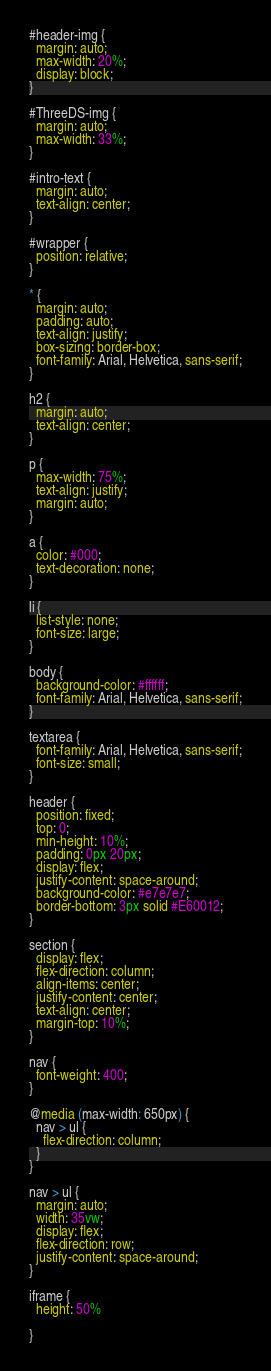<code> <loc_0><loc_0><loc_500><loc_500><_CSS_>#header-img {
  margin: auto;
  max-width: 20%;
  display: block;
}

#ThreeDS-img {
  margin: auto;
  max-width: 33%;
}

#intro-text {
  margin: auto;
  text-align: center;
}

#wrapper {
  position: relative;
}

* {
  margin: auto;
  padding: auto;
  text-align: justify;
  box-sizing: border-box;
  font-family: Arial, Helvetica, sans-serif;
}

h2 {
  margin: auto;
  text-align: center;
}

p {
  max-width: 75%;
  text-align: justify;
  margin: auto;
}

a {
  color: #000;
  text-decoration: none;
}

li {
  list-style: none;
  font-size: large;
}

body {
  background-color: #ffffff;
  font-family: Arial, Helvetica, sans-serif;
}

textarea {
  font-family: Arial, Helvetica, sans-serif;
  font-size: small;
}

header {
  position: fixed;
  top: 0;
  min-height: 10%;
  padding: 0px 20px;
  display: flex;
  justify-content: space-around;
  background-color: #e7e7e7;
  border-bottom: 3px solid #E60012;
}

section {
  display: flex;
  flex-direction: column;
  align-items: center;
  justify-content: center;
  text-align: center;
  margin-top: 10%;
}

nav {
  font-weight: 400;
}

@media (max-width: 650px) {
  nav > ul {
    flex-direction: column;
  }
}

nav > ul {
  margin: auto;
  width: 35vw;
  display: flex;
  flex-direction: row;
  justify-content: space-around;
}

iframe {
  height: 50%
  
}

</code> 